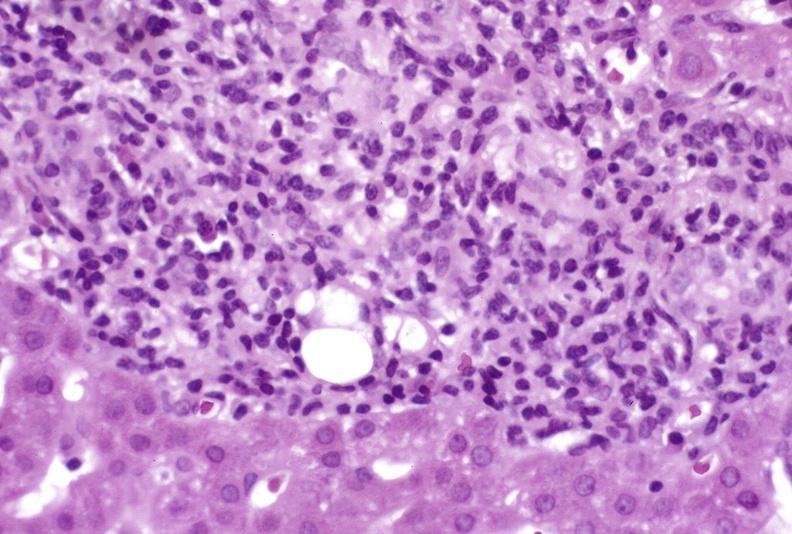does child show mild-to-moderate acute rejection?
Answer the question using a single word or phrase. No 